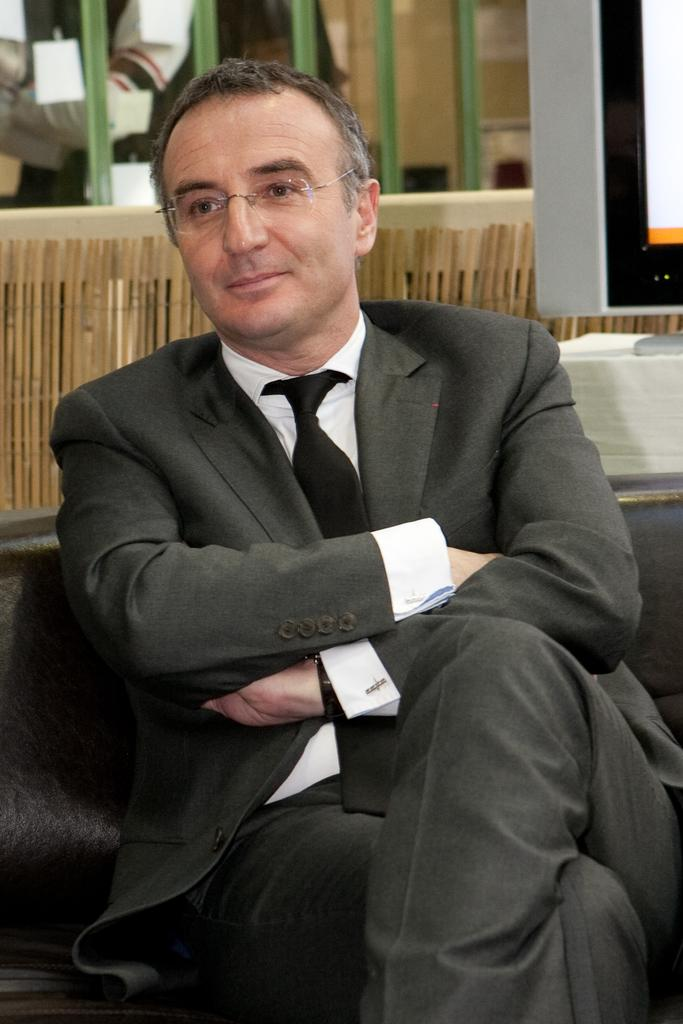What is the man in the image doing? The man is sitting in the image. What is the man wearing? The man is wearing a blazer. What accessory does the man have? The man has spectacles. What expression does the man have? The man is smiling. What can be seen in the background of the image? There is a television and a wooden wall in the background of the image. How many birds are perched on the man's tongue in the image? There are no birds present in the image, and the man's tongue is not visible. 